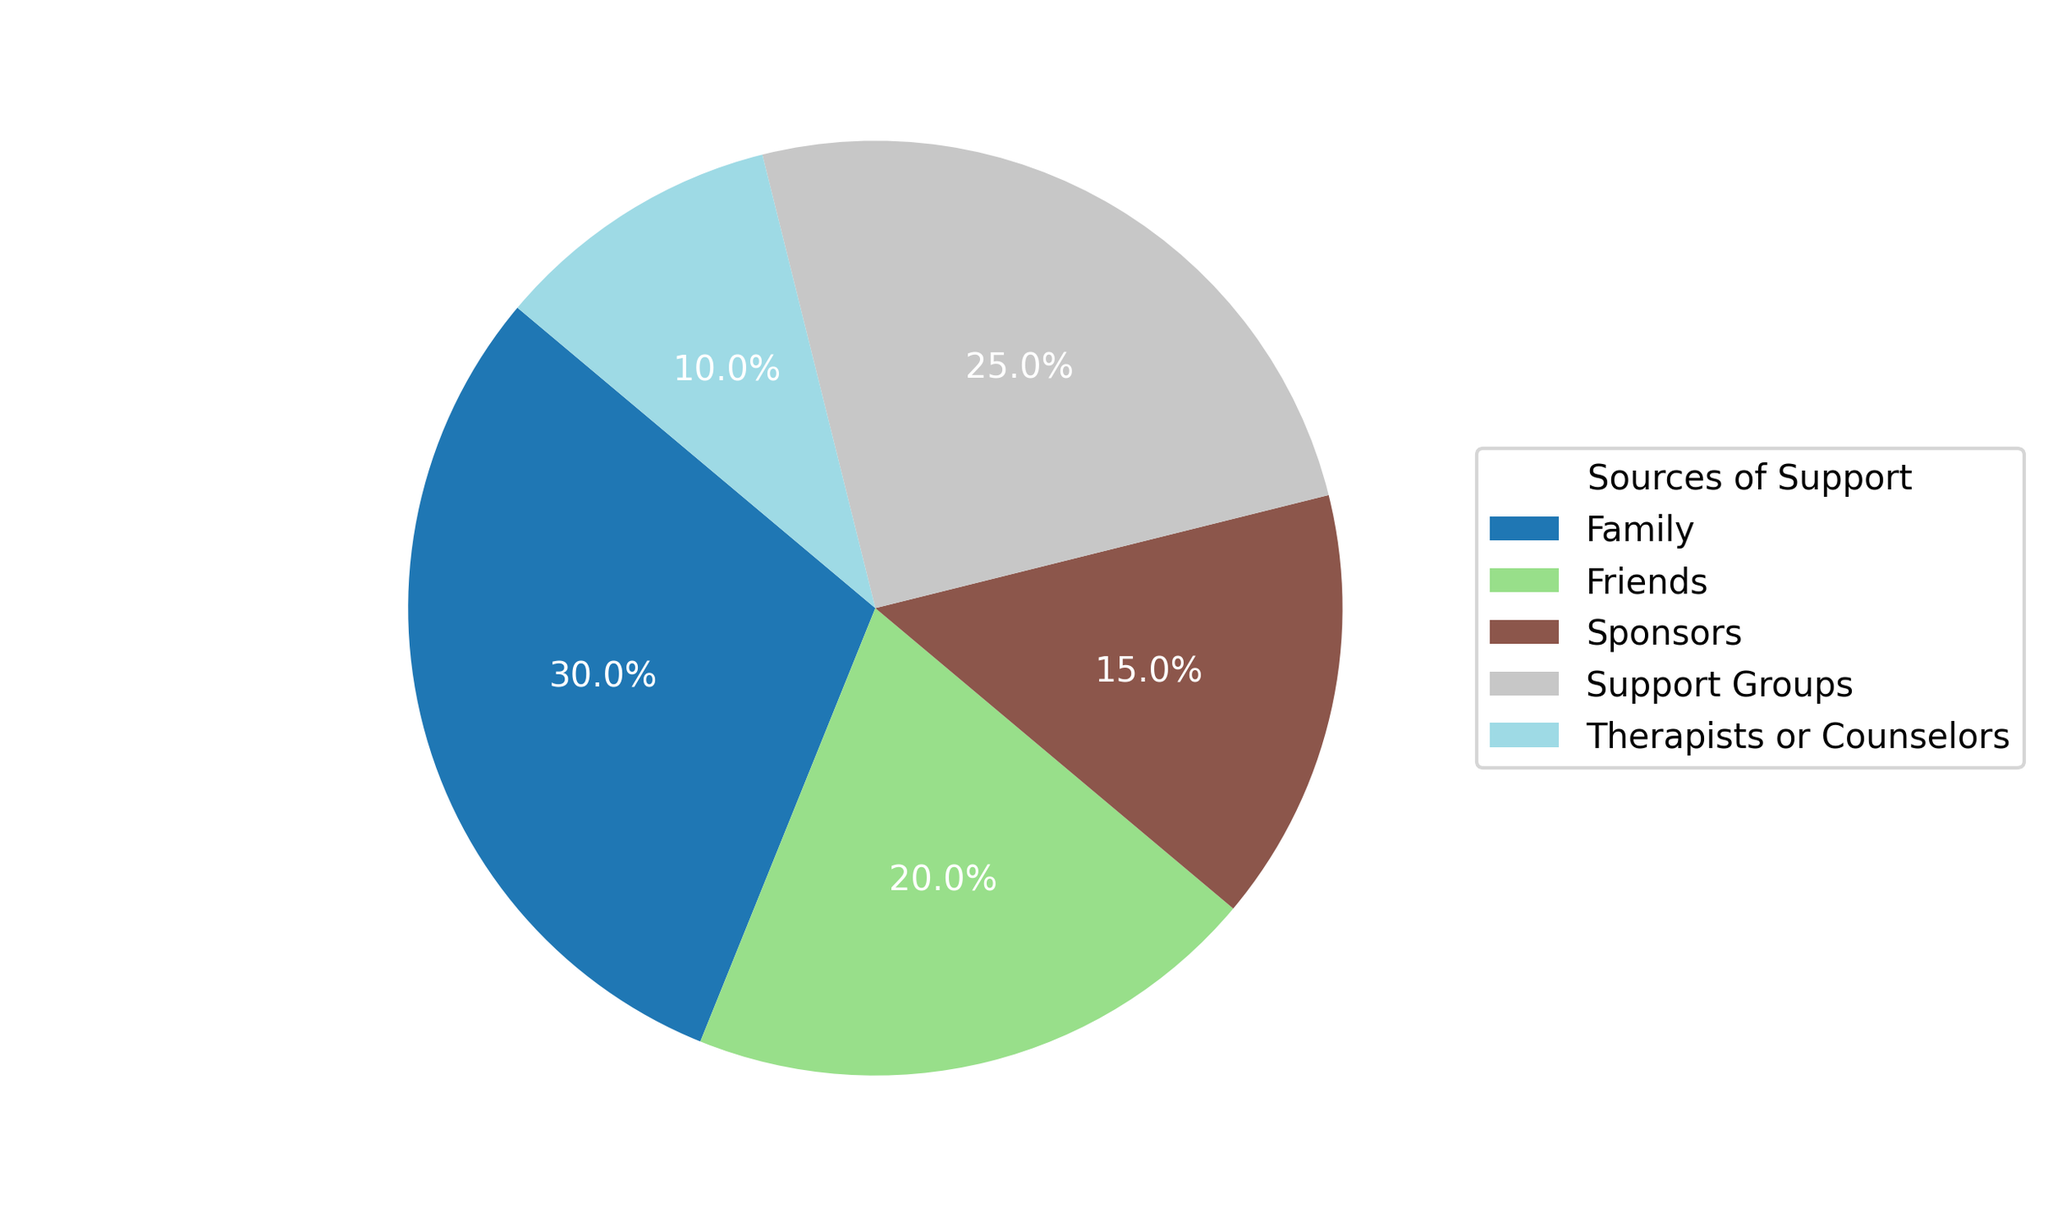What percentage of emotional support comes from family and friends combined? To find the total percentage of emotional support from family and friends combined, add the percentage from family (30%) and from friends (20%). Therefore, 30% + 20% = 50%.
Answer: 50% Which source provides the least amount of emotional support? By examining the pie chart, Therapists or Counselors contribute the lowest percentage of emotional support at 10%.
Answer: Therapists or Counselors Is the percentage of support from sponsors greater than or equal to that from therapists and counselors? By looking at both percentages, support from sponsors is 15% while from therapists and counselors is 10%. Since 15% is greater than 10%, support from sponsors is greater.
Answer: Greater What is the difference in percentage of support between support groups and therapists or counselors? The percentage of support from support groups is 25% and from therapists or counselors is 10%. Subtracting 10% from 25% gives 15%.
Answer: 15% What percentage of emotional support is provided by sources other than family? To find the support provided by sources other than family, subtract the percentage of family support (30%) from 100%. Thus, 100% - 30% = 70%.
Answer: 70% Which source provides more support: friends or support groups? Friends provide 20% of emotional support, while support groups provide 25%. Therefore, support groups provide more.
Answer: Support Groups What percentage of emotional support is derived from non-peer sources (Therapists or Counselors and Sponsors)? Summing the percentages from Therapists or Counselors (10%) and Sponsors (15%) gives 10% + 15% = 25%.
Answer: 25% Is the combined support from friends and sponsors more than that from family alone? Friends provide 20% and sponsors provide 15%, which together is 20% + 15% = 35%. This is more than the 30% provided by family alone.
Answer: Yes Which source has a higher percentage: family or all other sources combined? Family provides 30% support. Summing the percentages of all other sources: Friends (20%), Sponsors (15%), Support Groups (25%), and Therapists or Counselors (10%) gives 20% + 15% + 25% + 10% = 70%. 70% is greater than 30%.
Answer: All other sources combined How many sources contribute less than 20% each to emotional support? Based on the chart, the sources contributing less than 20% are Sponsors (15%) and Therapists or Counselors (10%). Two sources meet this criterion.
Answer: 2 